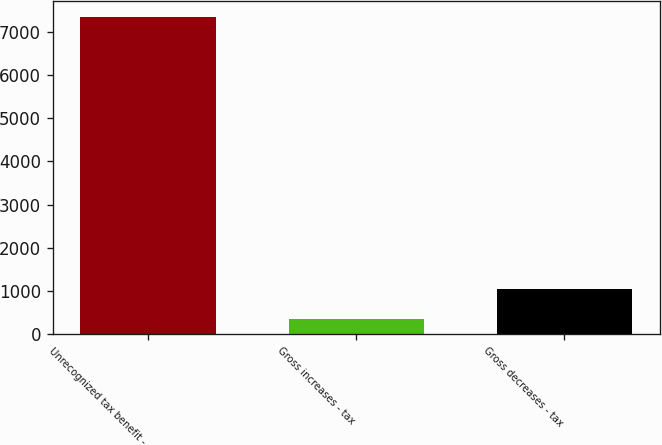Convert chart to OTSL. <chart><loc_0><loc_0><loc_500><loc_500><bar_chart><fcel>Unrecognized tax benefit -<fcel>Gross increases - tax<fcel>Gross decreases - tax<nl><fcel>7343<fcel>343<fcel>1043<nl></chart> 